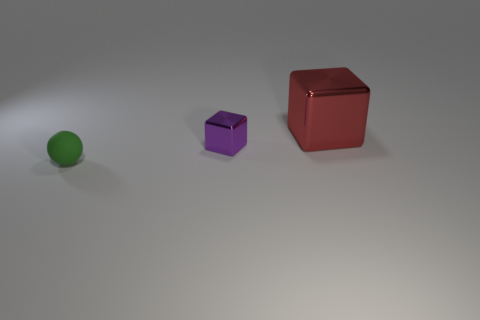What is the approximate size comparison between the three objects we can see in the image? In the image, the red cube appears to be the largest object, with the green sphere being the second largest, although size can be deceptive due to perspective. The purple cube is the smallest object among the three. 